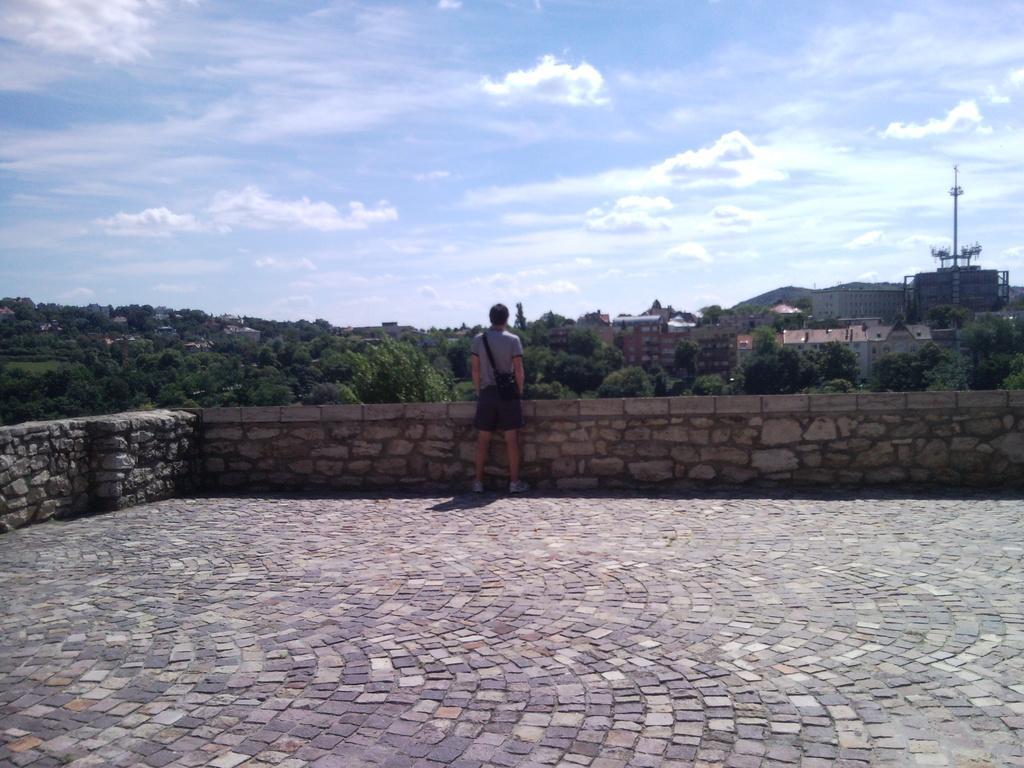Describe this image in one or two sentences. In this image we can see a person standing and we can also see boundary walls, trees, houses, electrical pole and sky. 